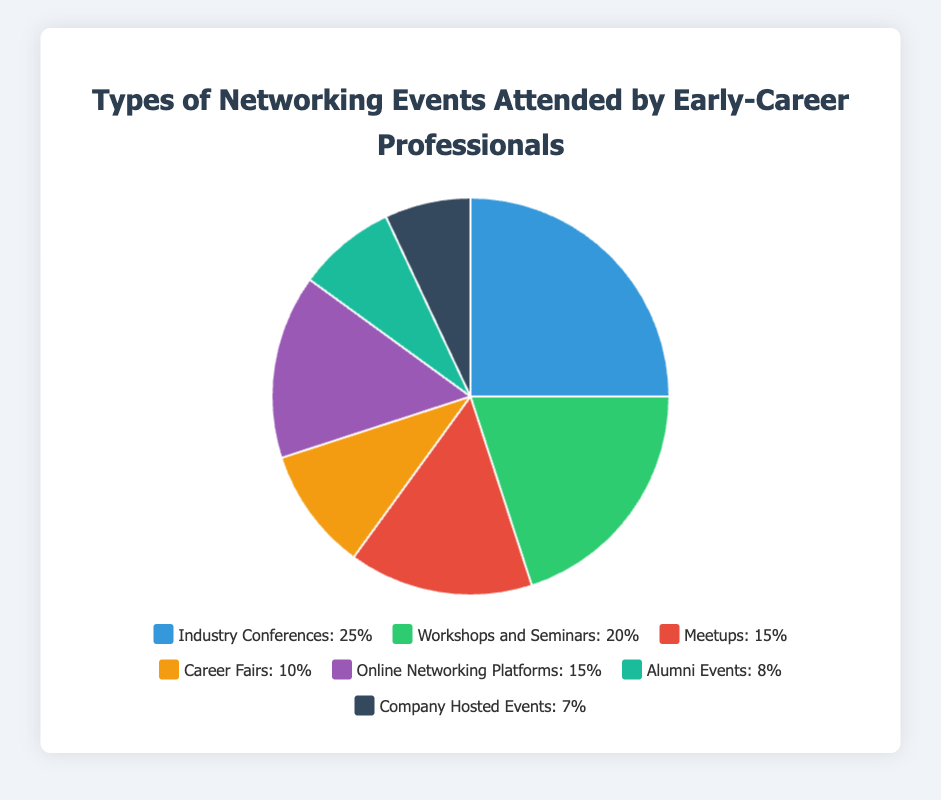What type of networking event is attended by the largest percentage of early-career professionals? The pie chart shows different types of networking events with their corresponding percentages. The largest percentage is 25% for Industry Conferences.
Answer: Industry Conferences What percentage of early-career professionals attend Meetups? The pie chart includes Meetups as one of the event types, representing 15%.
Answer: 15% Which two types of networking events have the same percentage of attendance? By examining the pie chart, two event types are labeled with the same percentage: Meetups and Online Networking Platforms, both at 15%.
Answer: Meetups and Online Networking Platforms What is the combined percentage of early-career professionals attending Career Fairs and Company Hosted Events? Career Fairs are 10% and Company Hosted Events are 7%. Adding these together: 10% + 7% = 17%.
Answer: 17% Which type of networking event is represented by the purple segment of the pie chart? The legend matches colors to event types, showing that the purple segment corresponds to Online Networking Platforms, which is 15% of the total.
Answer: Online Networking Platforms What is the difference in percentage between Industry Conferences and Workshops and Seminars? Industry Conferences are at 25% while Workshops and Seminars are at 20%. The difference is 25% - 20% = 5%.
Answer: 5% How many types of networking events have a percentage of 10% or more? The pie chart shows Industry Conferences (25%), Workshops and Seminars (20%), Meetups (15%), Online Networking Platforms (15%), and Career Fairs (10%). This totals 5 event types.
Answer: 5 What percentage of early-career professionals attend Alumni Events? The pie chart displays Alumni Events as having a percentage of 8%.
Answer: 8% If an event type were to increase by 5% and become more attended than Career Fairs, what would be the new percentage of that event type? Career Fairs are currently attended by 10%. An event type would need to increase from less than 10% to overtake Career Fairs. For example, Company Hosted Events (currently 7%) increasing by 5% would lead to 7% + 5% = 12%.
Answer: 12% Which event type has the smallest percentage, and what is that percentage? The pie chart indicates that Company Hosted Events have the smallest percentage at 7%.
Answer: Company Hosted Events, 7% 